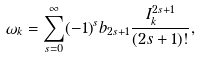Convert formula to latex. <formula><loc_0><loc_0><loc_500><loc_500>\omega _ { k } = \sum _ { s = 0 } ^ { \infty } ( - 1 ) ^ { s } b _ { 2 s + 1 } \frac { I _ { k } ^ { 2 s + 1 } } { ( 2 s + 1 ) ! } ,</formula> 